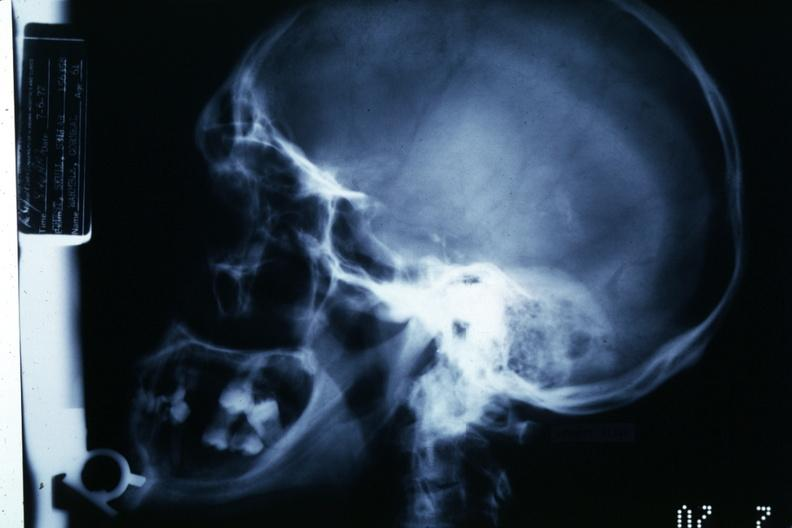what is present?
Answer the question using a single word or phrase. Bone 